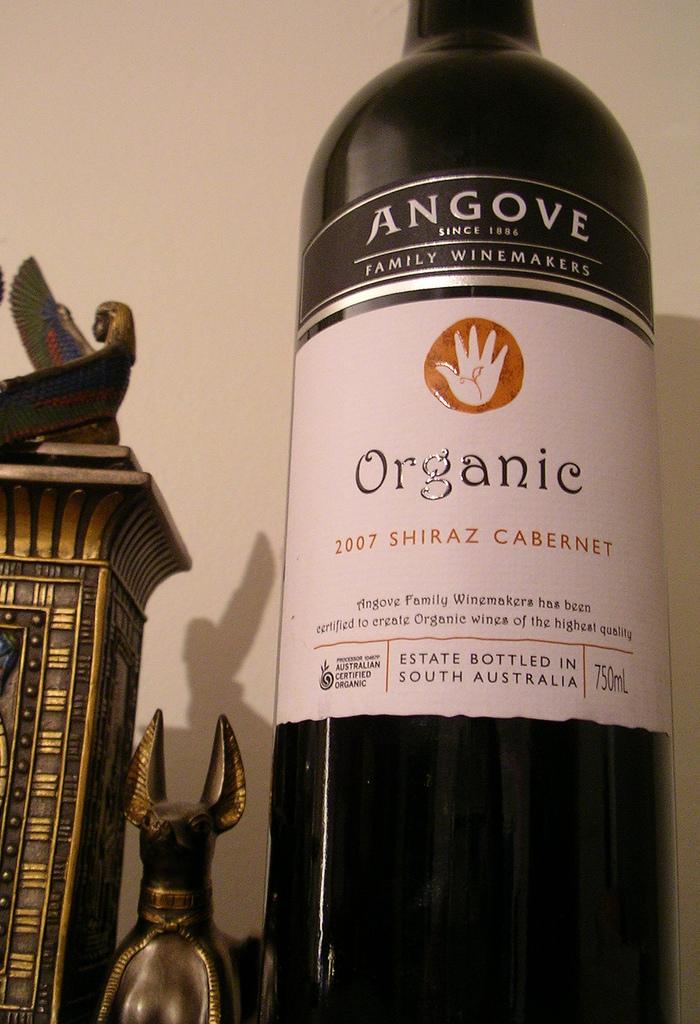Where was this bottled at?
Your answer should be compact. South australia. Is the wine organic?
Your answer should be very brief. Yes. 